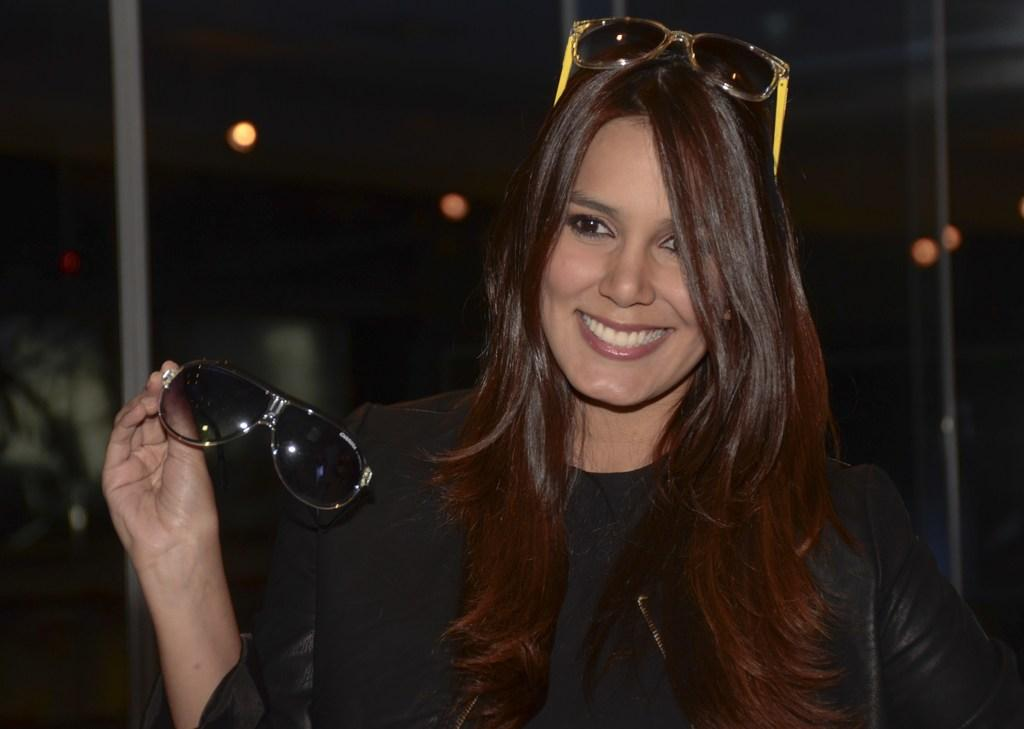Who is the main subject in the image? There is a lady in the center of the image. What is the lady wearing? The lady is wearing glasses. What is the lady's facial expression? The lady is smiling. What is the lady holding in her hand? The lady is holding glasses. What can be seen in the background of the image? There are lights and poles in the background of the image. What type of grain is visible in the image? There is no grain present in the image. How does the moon affect the lighting in the image? The image does not show the moon, so its effect on the lighting cannot be determined. 